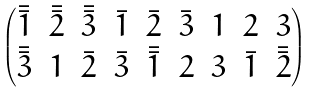Convert formula to latex. <formula><loc_0><loc_0><loc_500><loc_500>\begin{pmatrix} \bar { \bar { 1 } } & \bar { \bar { 2 } } & \bar { \bar { 3 } } & \bar { 1 } & \bar { 2 } & \bar { 3 } & 1 & 2 & 3 \\ \bar { \bar { 3 } } & 1 & \bar { 2 } & \bar { 3 } & \bar { \bar { 1 } } & 2 & 3 & \bar { 1 } & \bar { \bar { 2 } } \end{pmatrix}</formula> 